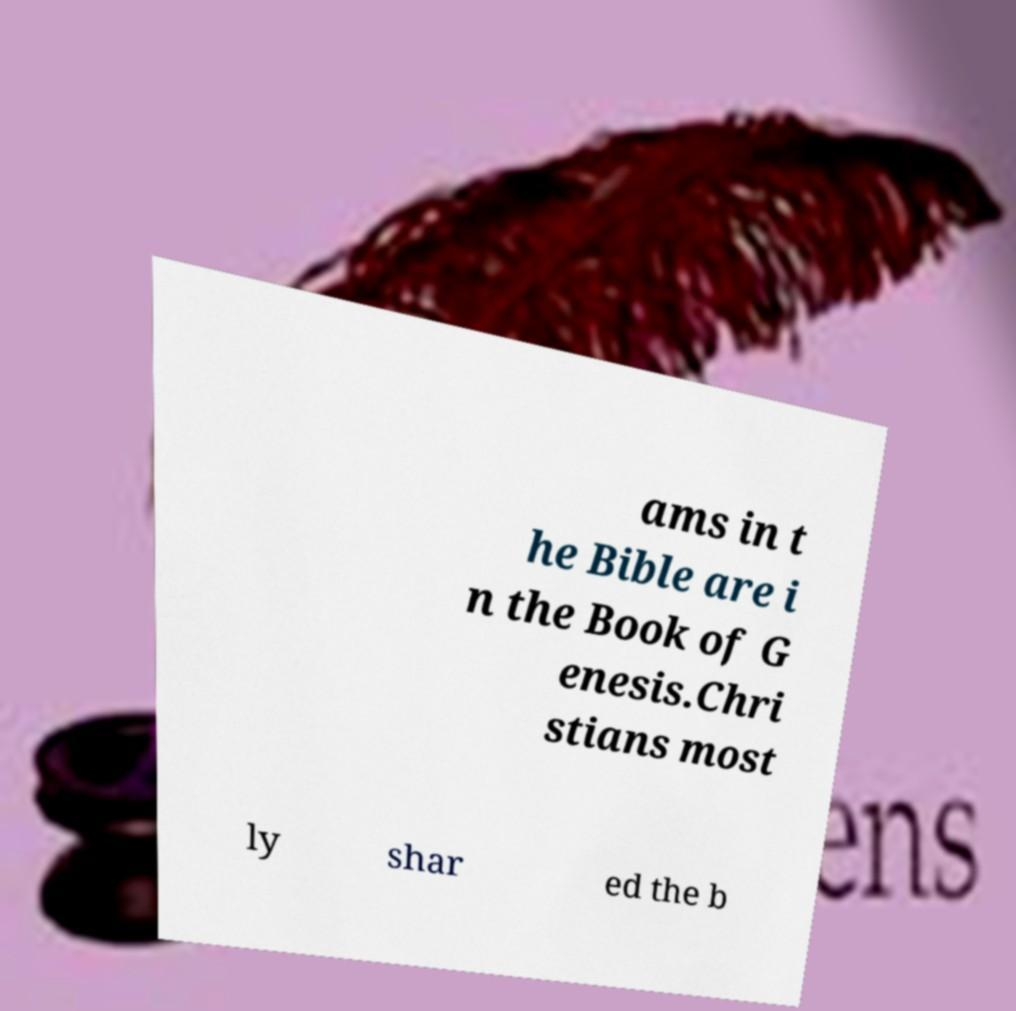Can you accurately transcribe the text from the provided image for me? ams in t he Bible are i n the Book of G enesis.Chri stians most ly shar ed the b 